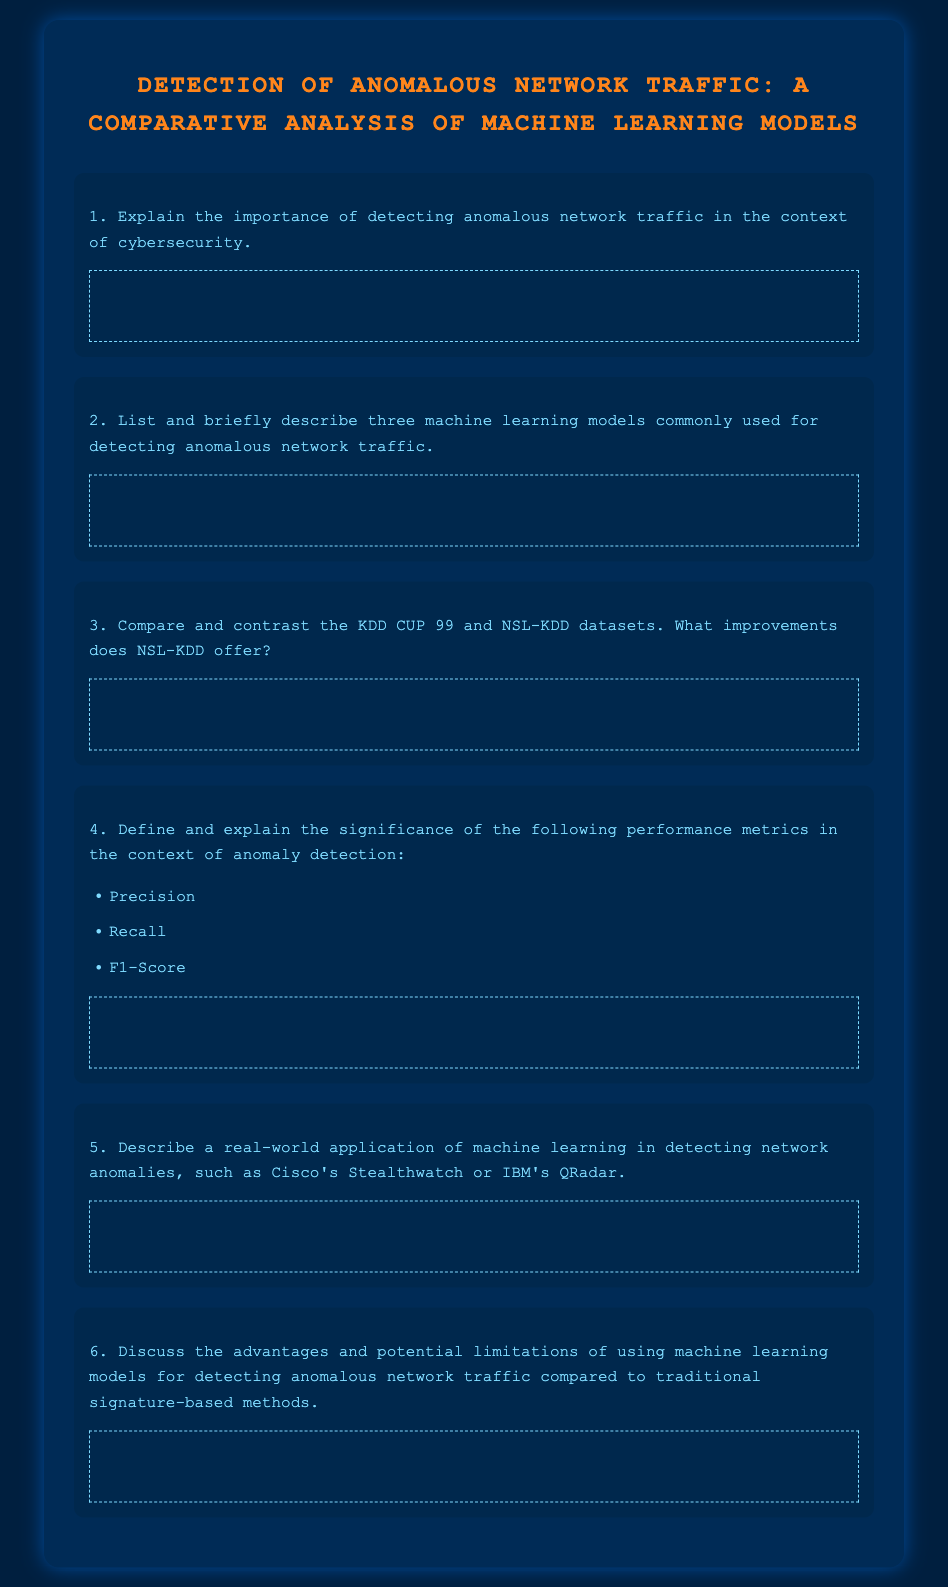What is the title of the document? The title is stated at the top of the document, highlighting the main focus of the content.
Answer: Detection of Anomalous Network Traffic: A Comparative Analysis of Machine Learning Models How many questions are included in the exam? The document lists a total of six questions for the exam.
Answer: 6 What color is used for the main heading (h1)? The color specified for the main heading in the CSS is orange, which is indicated by the hex code.
Answer: #FF851B Which dataset is mentioned as having improvements over KDD CUP 99? This dataset is known for addressing some limitations of its predecessor and is explicitly stated in one of the questions.
Answer: NSL-KDD What metric is defined as the harmonic mean of precision and recall? The question refers to a specific metric that combines these two performance measures and is mentioned directly in the document.
Answer: F1-Score Name one real-world application of machine learning for detecting network anomalies. The document asks for examples of applications, and prominent technology solutions are commonly cited.
Answer: Cisco's Stealthwatch 